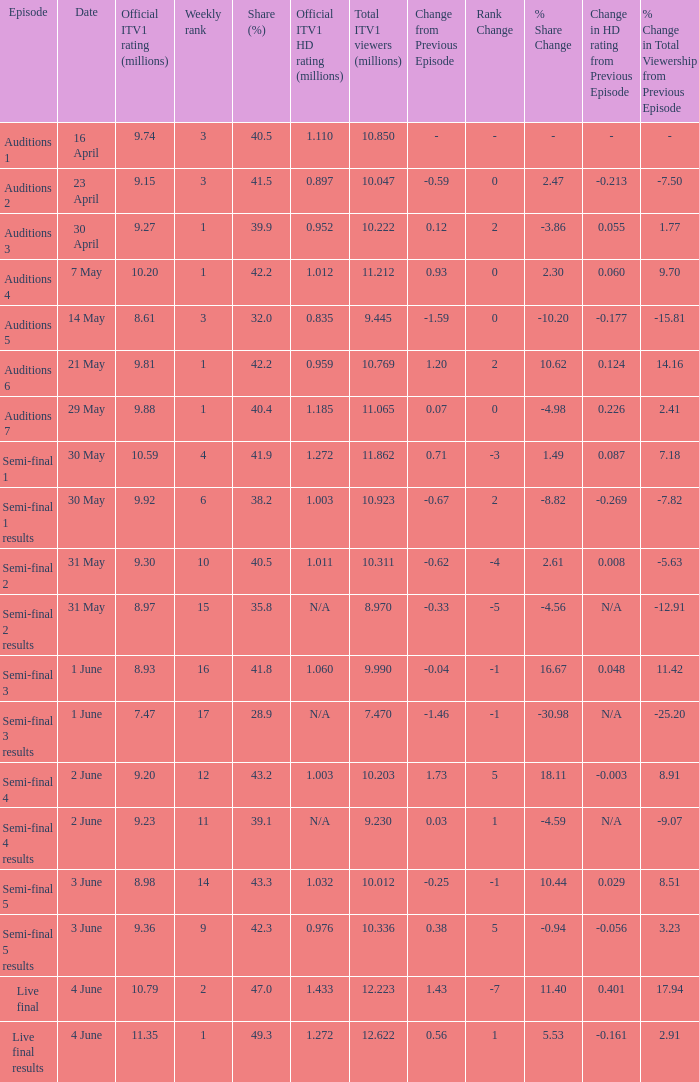When was the episode that had a share (%) of 41.5? 23 April. 